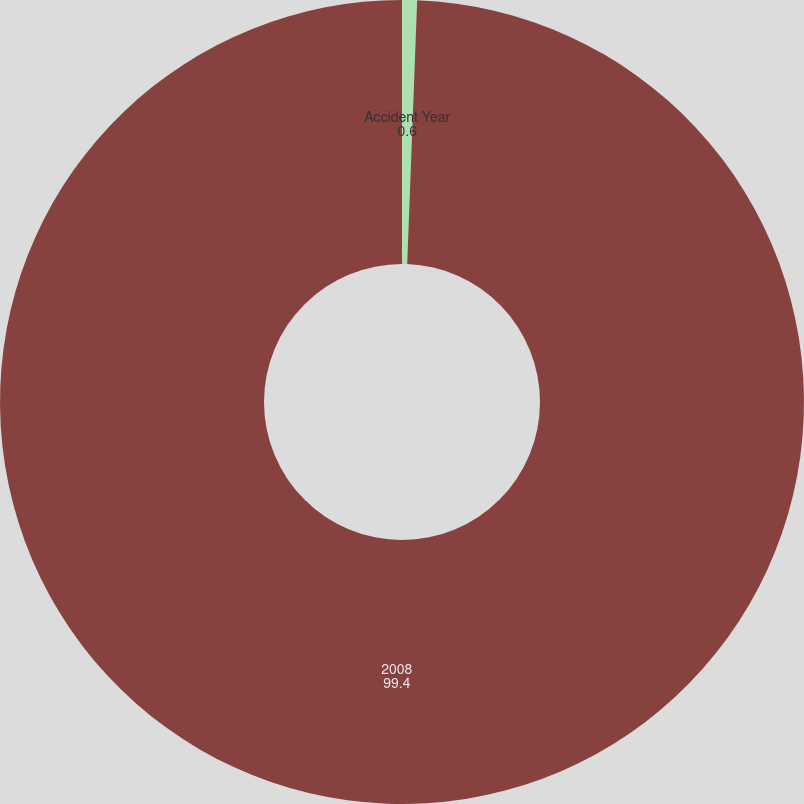Convert chart to OTSL. <chart><loc_0><loc_0><loc_500><loc_500><pie_chart><fcel>Accident Year<fcel>2008<nl><fcel>0.6%<fcel>99.4%<nl></chart> 